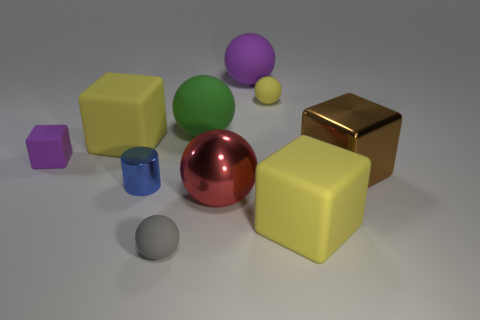Subtract 2 balls. How many balls are left? 3 Subtract all red spheres. How many spheres are left? 4 Subtract all green matte balls. How many balls are left? 4 Subtract all cyan spheres. Subtract all red blocks. How many spheres are left? 5 Subtract all cylinders. How many objects are left? 9 Add 3 small blue cylinders. How many small blue cylinders exist? 4 Subtract 0 cyan balls. How many objects are left? 10 Subtract all large brown metallic blocks. Subtract all yellow matte spheres. How many objects are left? 8 Add 6 small yellow matte balls. How many small yellow matte balls are left? 7 